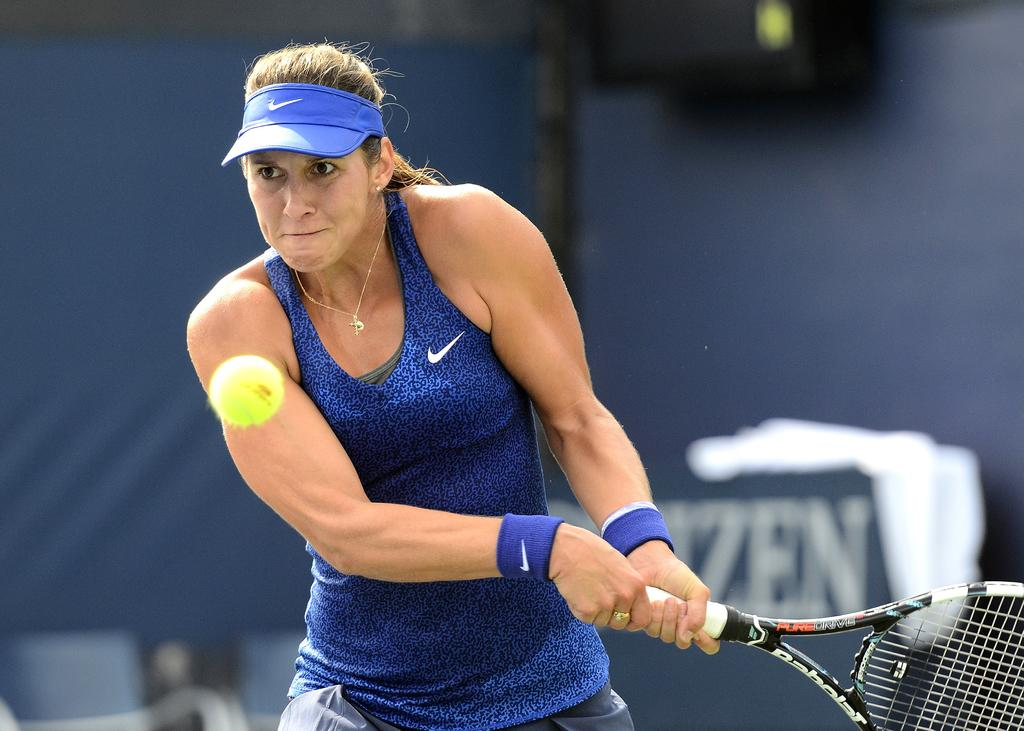Who is present in the image? There is a woman in the image. What is the woman wearing on her upper body? The woman is wearing a blue top. What object is the woman holding in the image? The woman is holding a bat. What type of headwear is the woman wearing? The woman is wearing a blue cap. What other object can be seen in the image? There is a ball visible in the image. What type of juice is the woman drinking in the image? There is no juice present in the image; the woman is holding a bat and wearing a blue cap. 